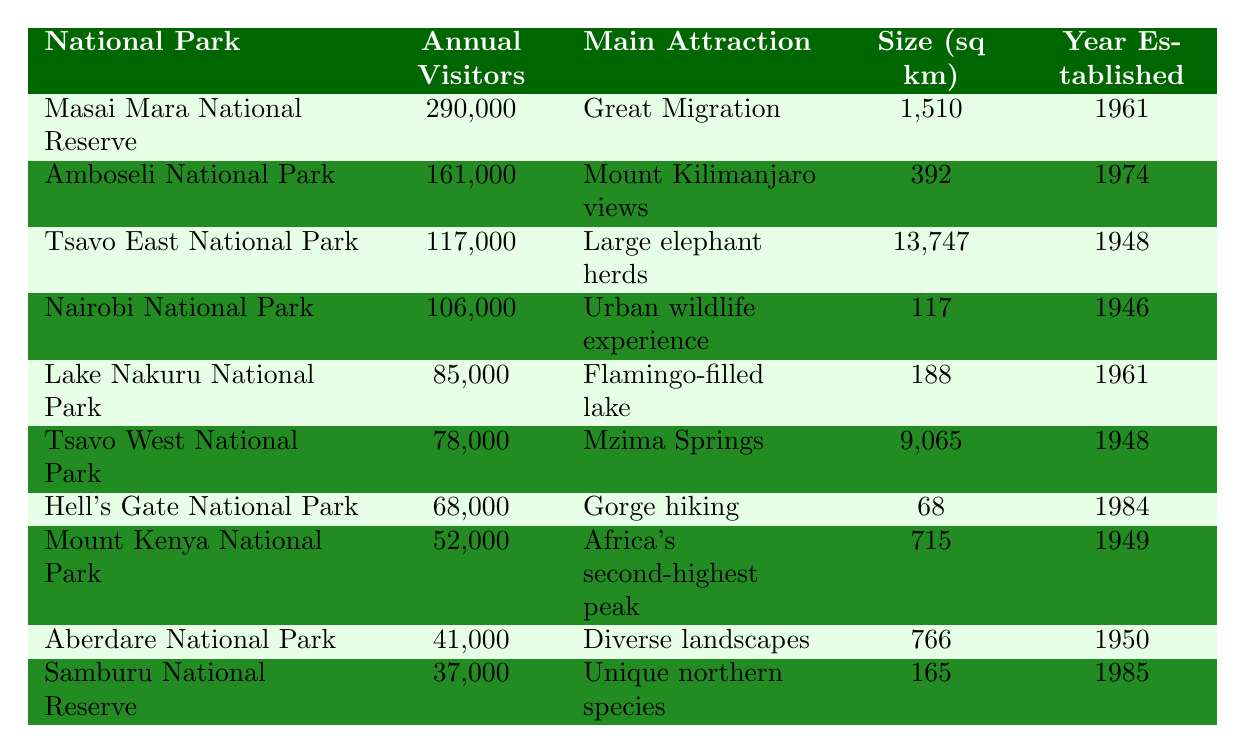What is the most visited national park in Kenya? The table shows that Masai Mara National Reserve has the highest annual visitor count at 290,000.
Answer: Masai Mara National Reserve How many annual visitors does Amboseli National Park receive? By looking at the table, Ambosei National Park has an annual visitor count of 161,000.
Answer: 161,000 What is the main attraction of Tsavo East National Park? The table indicates that the main attraction of Tsavo East National Park is "Large elephant herds".
Answer: Large elephant herds Which national park has the smallest size in square kilometers? The table shows that Hell's Gate National Park has the smallest area at 68 square kilometers.
Answer: Hell's Gate National Park How many more annual visitors does Masai Mara have than Lake Nakuru National Park? The annual visitors for Masai Mara are 290,000, and for Lake Nakuru, it is 85,000. The difference is 290,000 - 85,000 = 205,000.
Answer: 205,000 Is Nairobi National Park larger than Lake Nakuru National Park? Nairobi National Park has an area of 117 sq km while Lake Nakuru has an area of 188 sq km, thus Nairobi National Park is smaller.
Answer: No Which park has both an established year and a size larger than 1,000 square kilometers? Tsavo East National Park (1948, 13,747 sq km) meets both criteria; it was established in 1948 and is over 1,000 sq km.
Answer: Tsavo East National Park What is the average annual visitor count for the top three national parks? The top three parks are Masai Mara (290,000), Amboseli (161,000), and Tsavo East (117,000). Their average is (290,000 + 161,000 + 117,000) / 3 = 189,333.
Answer: 189,333 Which national park was established most recently, and what is its main attraction? Samburu National Reserve established in 1985 is the most recently established park and has "Unique northern species" as its main attraction.
Answer: Samburu National Reserve; Unique northern species How many parks have an annual visitor count of over 100,000? From the table, four parks have visitor counts over 100,000: Masai Mara, Amboseli, Tsavo East, and Nairobi.
Answer: 4 